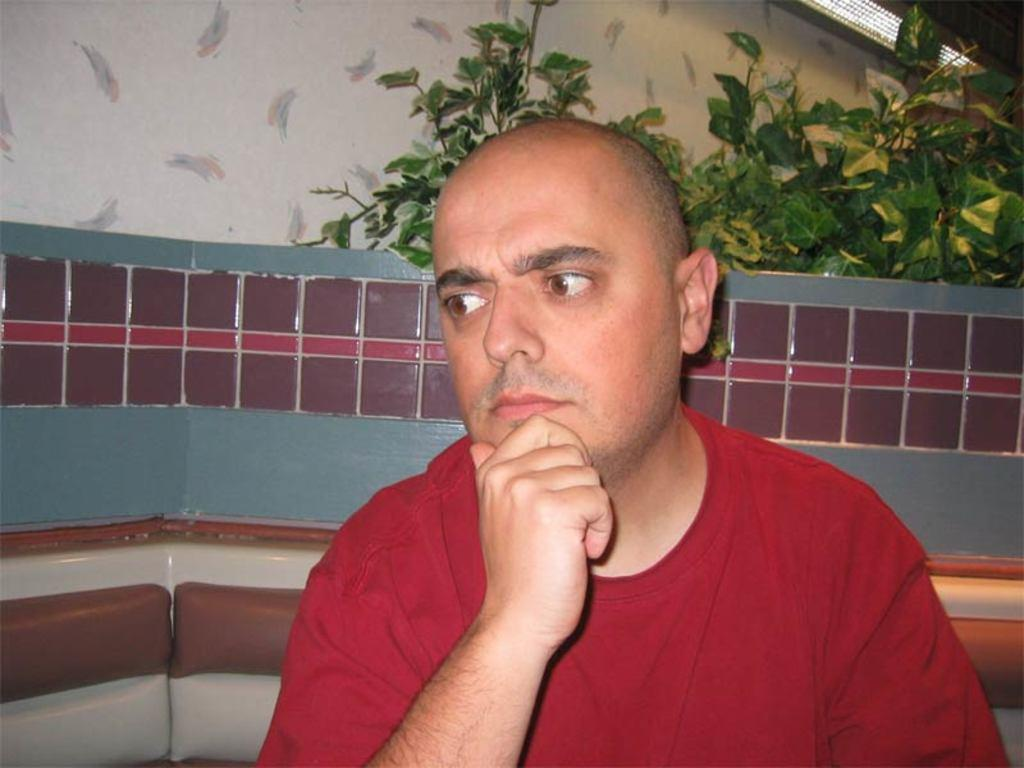What is present in the image? There is a man in the image. What is the man wearing? The man is wearing a red T-shirt. What can be seen behind the man in the image? There are plants visible behind the man in the image. How much sugar is visible on the man's red T-shirt in the image? There is no visible sugar on the man's red T-shirt in the image. What type of silver object can be seen in the man's hand in the image? There is no silver object visible in the man's hand in the image. 